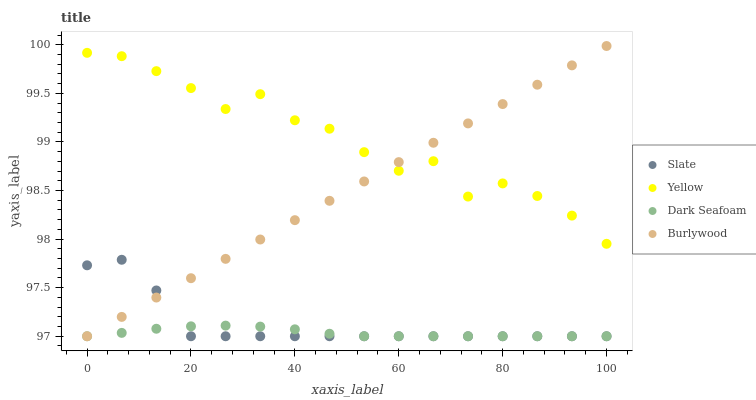Does Dark Seafoam have the minimum area under the curve?
Answer yes or no. Yes. Does Yellow have the maximum area under the curve?
Answer yes or no. Yes. Does Slate have the minimum area under the curve?
Answer yes or no. No. Does Slate have the maximum area under the curve?
Answer yes or no. No. Is Burlywood the smoothest?
Answer yes or no. Yes. Is Yellow the roughest?
Answer yes or no. Yes. Is Slate the smoothest?
Answer yes or no. No. Is Slate the roughest?
Answer yes or no. No. Does Burlywood have the lowest value?
Answer yes or no. Yes. Does Yellow have the lowest value?
Answer yes or no. No. Does Burlywood have the highest value?
Answer yes or no. Yes. Does Slate have the highest value?
Answer yes or no. No. Is Dark Seafoam less than Yellow?
Answer yes or no. Yes. Is Yellow greater than Dark Seafoam?
Answer yes or no. Yes. Does Burlywood intersect Slate?
Answer yes or no. Yes. Is Burlywood less than Slate?
Answer yes or no. No. Is Burlywood greater than Slate?
Answer yes or no. No. Does Dark Seafoam intersect Yellow?
Answer yes or no. No. 